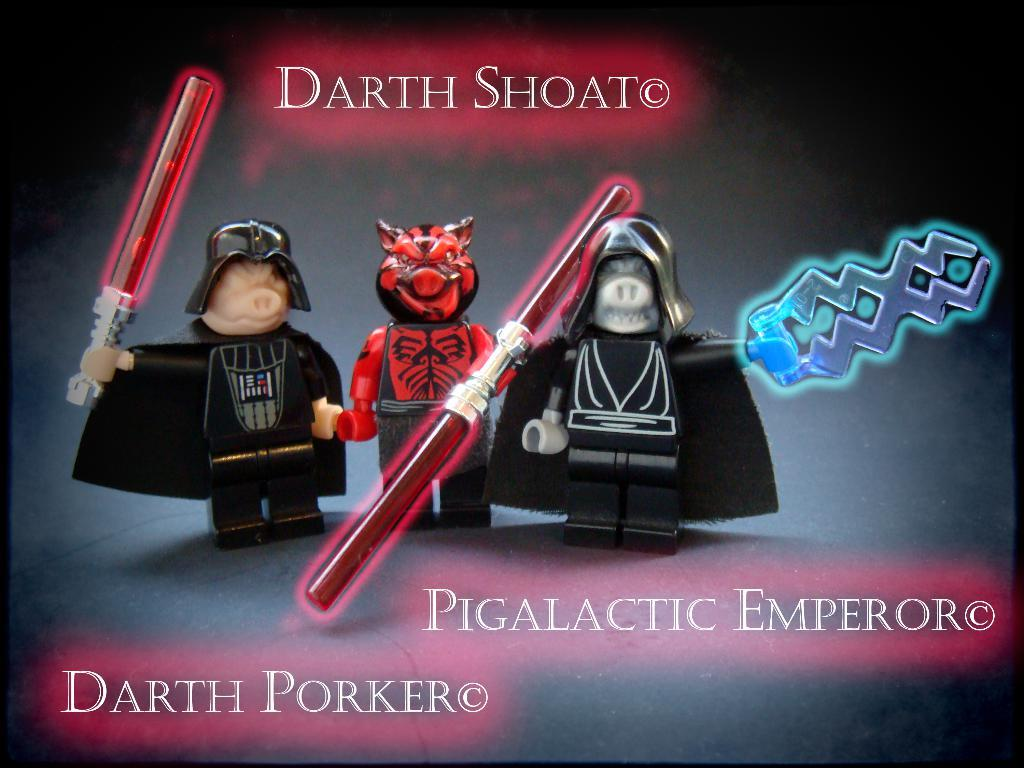What is featured in the image? There is a poster in the image. What can be seen on the poster? The poster contains three toys. Is there any text on the poster? Yes, there is text written on the poster. How many chairs are visible in the scene depicted on the poster? There is no scene depicted on the poster, as it only contains three toys and text. 